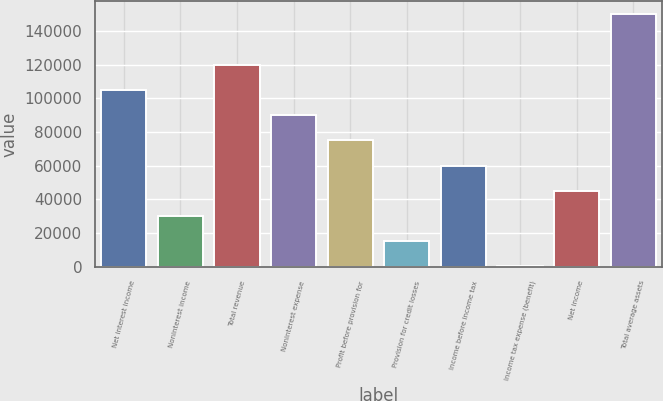Convert chart to OTSL. <chart><loc_0><loc_0><loc_500><loc_500><bar_chart><fcel>Net interest income<fcel>Noninterest income<fcel>Total revenue<fcel>Noninterest expense<fcel>Profit before provision for<fcel>Provision for credit losses<fcel>Income before income tax<fcel>Income tax expense (benefit)<fcel>Net income<fcel>Total average assets<nl><fcel>105045<fcel>30198.6<fcel>120014<fcel>90075.8<fcel>75106.5<fcel>15229.3<fcel>60137.2<fcel>260<fcel>45167.9<fcel>149953<nl></chart> 